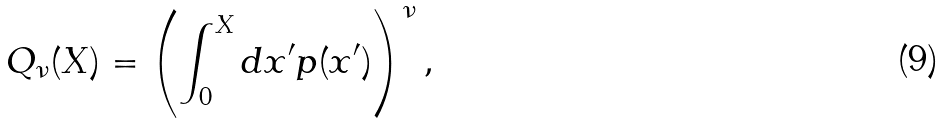<formula> <loc_0><loc_0><loc_500><loc_500>Q _ { \nu } ( X ) = \left ( \int _ { 0 } ^ { X } { d } x ^ { \prime } p ( x ^ { \prime } ) \right ) ^ { \nu } ,</formula> 